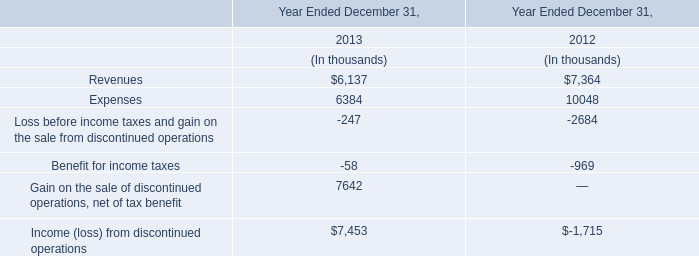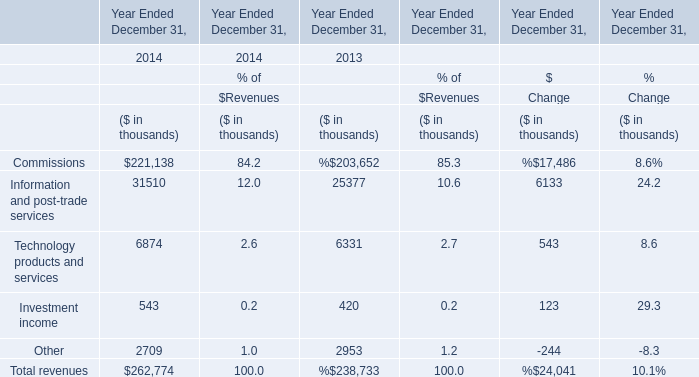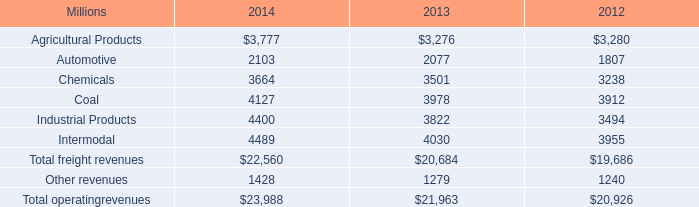What's the increasing rate of Investment income in 2014 Ended December 31? 
Computations: ((543 - 420) / 420)
Answer: 0.29286. 